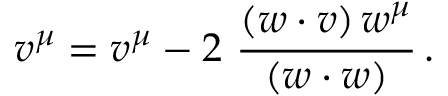Convert formula to latex. <formula><loc_0><loc_0><loc_500><loc_500>v ^ { \mu } = v ^ { \mu } - 2 \ \frac { ( w \cdot v ) \, w ^ { \mu } } { ( w \cdot w ) } \, .</formula> 